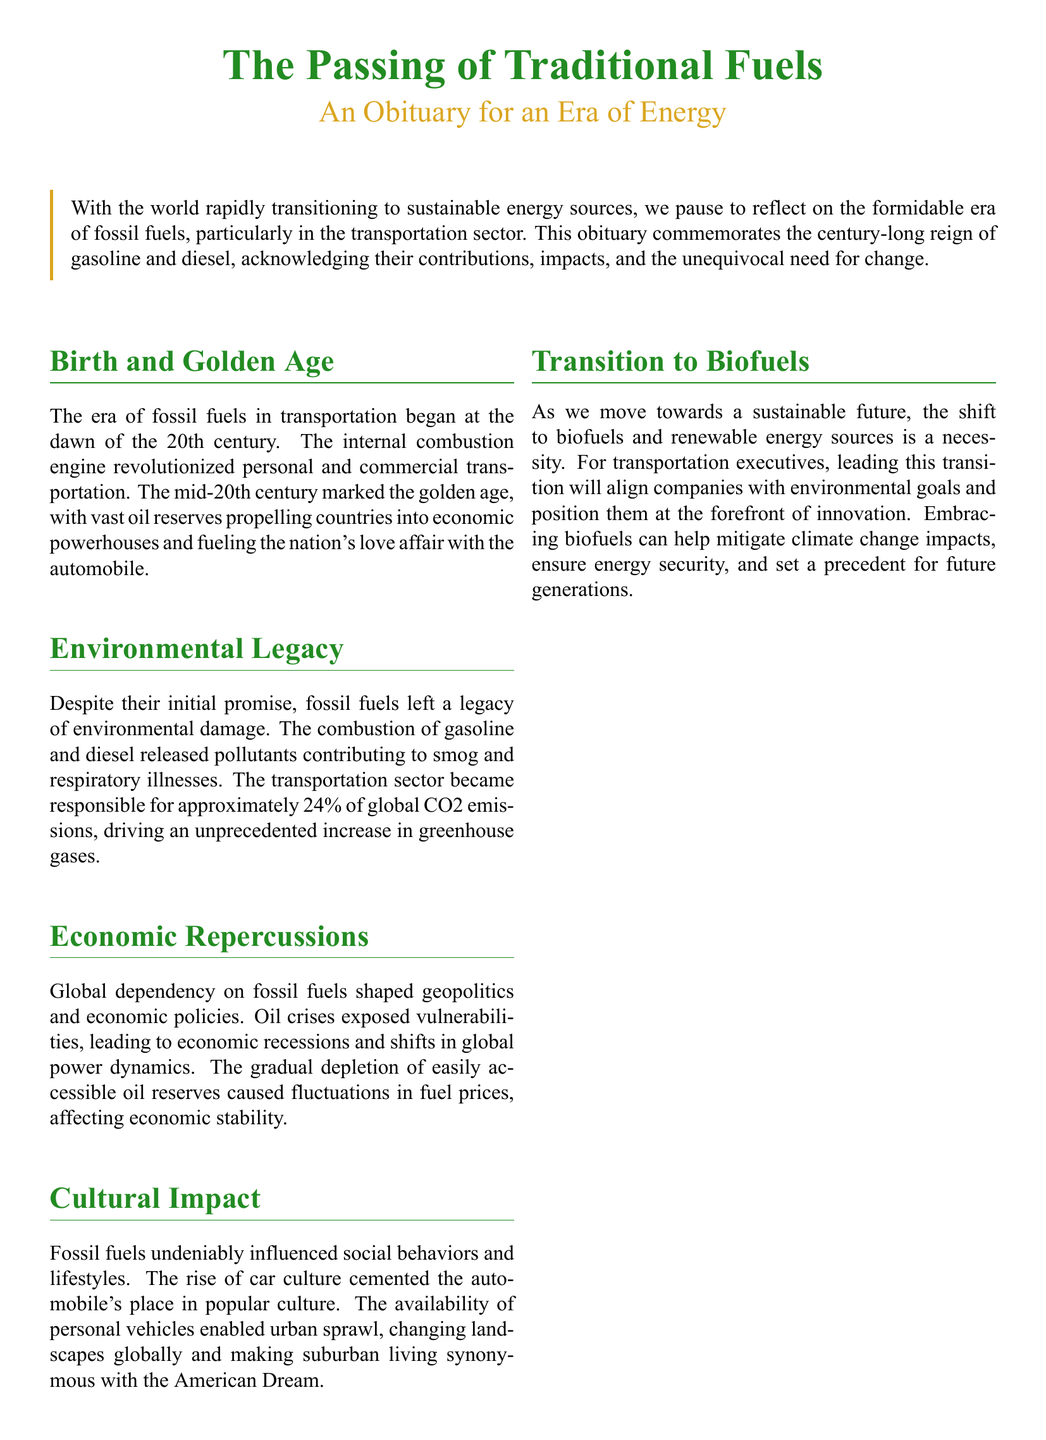What began the era of fossil fuels in transportation? The document mentions that the era began at the dawn of the 20th century with the internal combustion engine.
Answer: internal combustion engine What percentage of global CO2 emissions was the transportation sector responsible for? The document states that the transportation sector was responsible for approximately 24% of global CO2 emissions.
Answer: 24% What fueled the nation's love affair with the automobile during the mid-20th century? The document indicates that vast oil reserves propelled countries into economic powerhouses during this time.
Answer: vast oil reserves What cultural impact did fossil fuels have on social behaviors? The document notes that the rise of car culture cemented the automobile's place in popular culture.
Answer: car culture What is necessary for the transition to a sustainable future according to the document? The document emphasizes that the shift to biofuels and renewable energy sources is a necessity.
Answer: shift to biofuels What does the obituary signify regarding traditional fossil fuels? The document states that it signifies the end of one era and the hopeful beginning of another.
Answer: end of one era and the hopeful beginning of another What was a consequence of the global dependency on fossil fuels? The document points out that oil crises exposed vulnerabilities, leading to economic recessions.
Answer: economic recessions What does the document emphasize about transportation executives? It emphasizes that leading the transition to biofuels will align companies with environmental goals.
Answer: align companies with environmental goals 